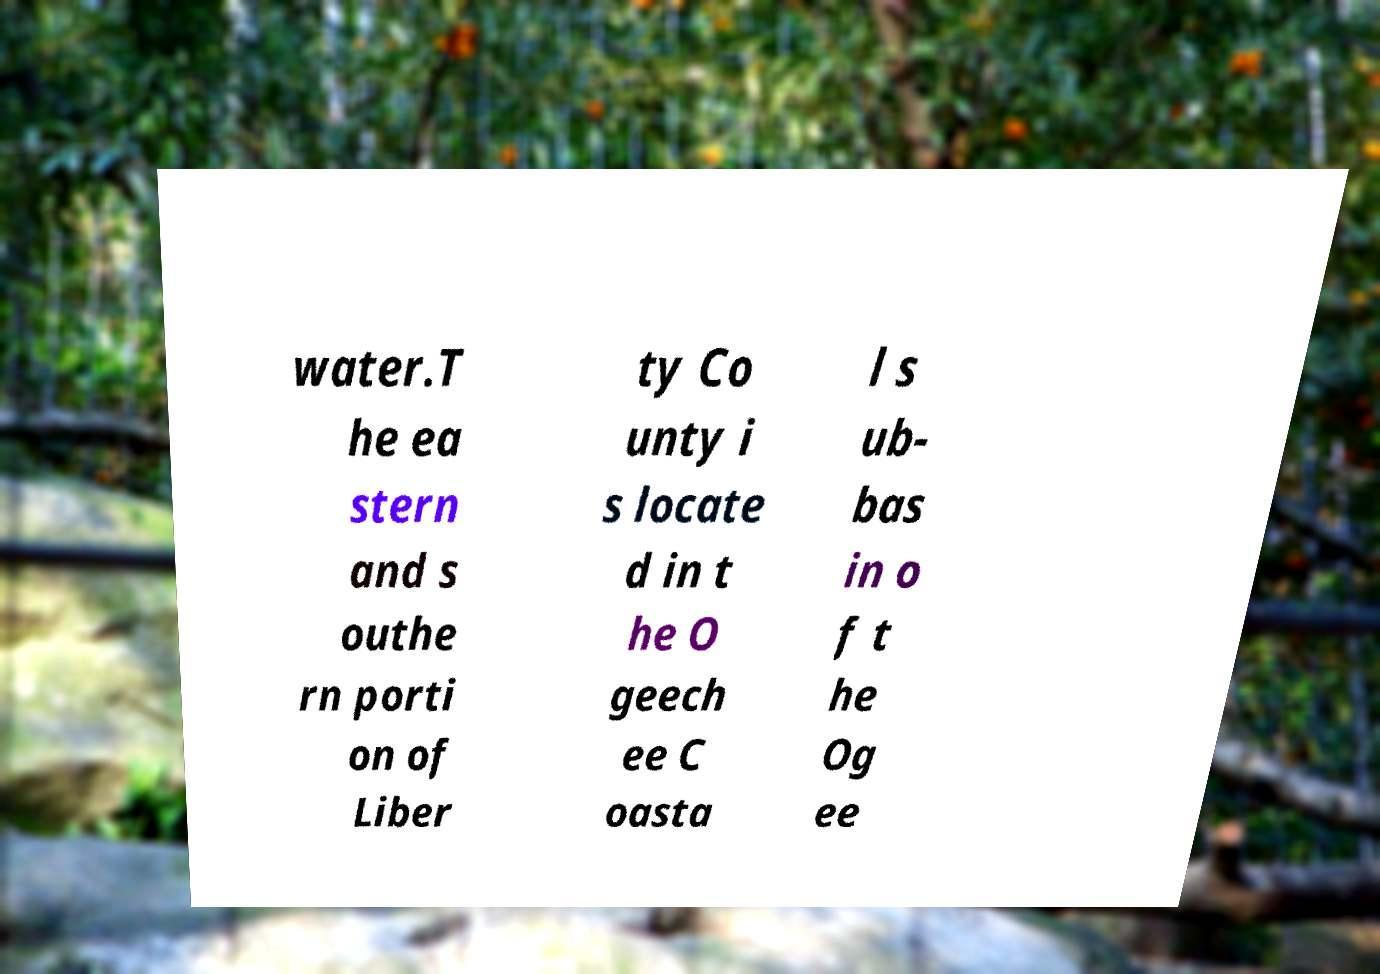There's text embedded in this image that I need extracted. Can you transcribe it verbatim? water.T he ea stern and s outhe rn porti on of Liber ty Co unty i s locate d in t he O geech ee C oasta l s ub- bas in o f t he Og ee 